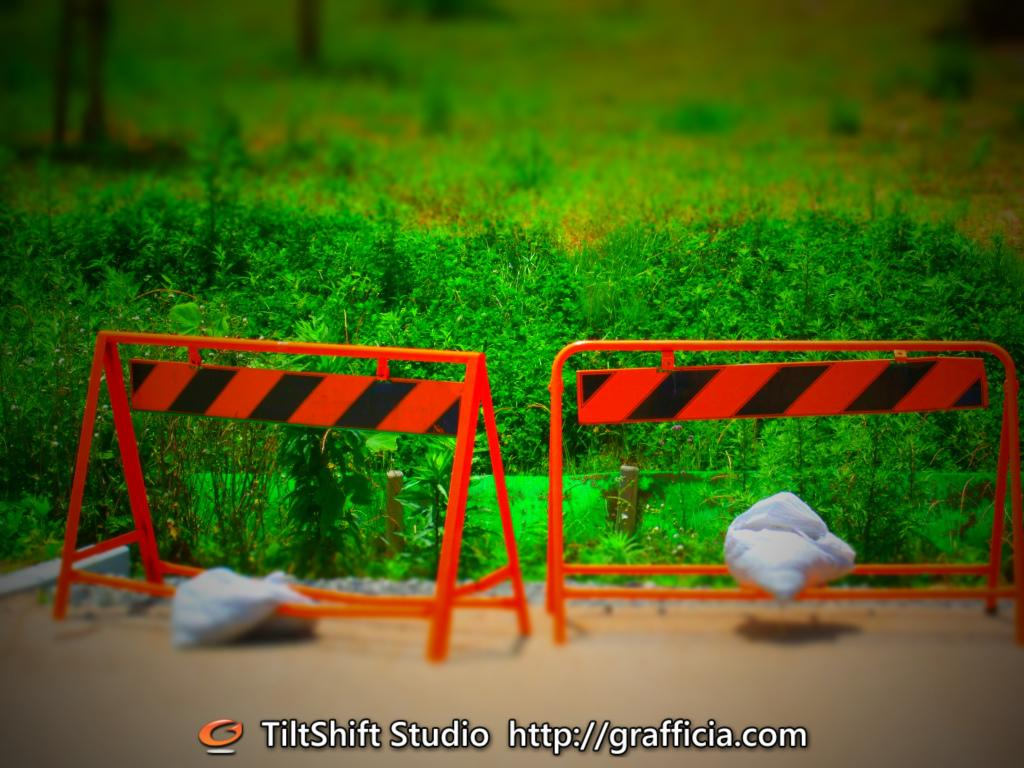What objects are on the ground in the image? There are bags and barricades on the ground in the image. What type of vegetation can be seen in the background of the image? There is grass visible in the background of the image. What additional feature is present on the image? There is a watermark on the image. How is the background of the image depicted? The background of the image is blurred. What type of silk is draped over the barricades in the image? There is no silk present in the image; it only features bags, barricades, and grass in the background. 